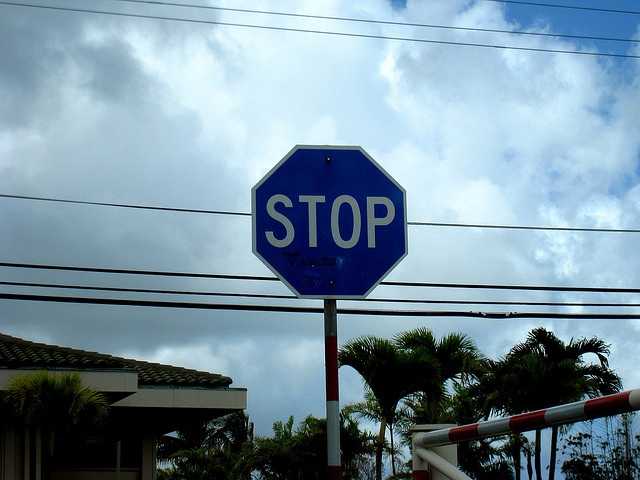Describe the objects in this image and their specific colors. I can see a stop sign in gray and navy tones in this image. 